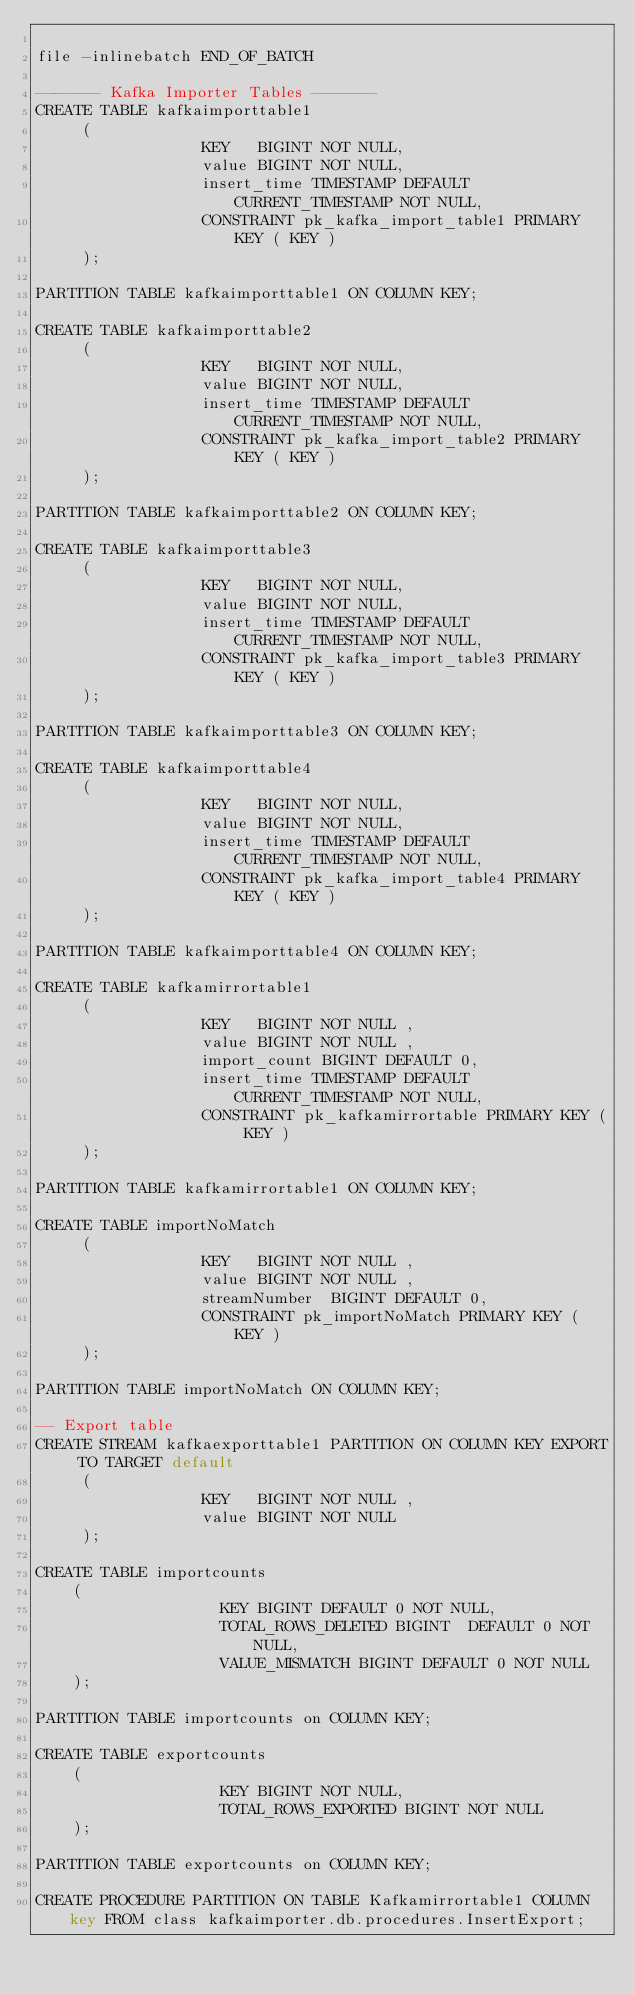<code> <loc_0><loc_0><loc_500><loc_500><_SQL_>
file -inlinebatch END_OF_BATCH

------- Kafka Importer Tables -------
CREATE TABLE kafkaimporttable1
     (
                  KEY   BIGINT NOT NULL,
                  value BIGINT NOT NULL,
                  insert_time TIMESTAMP DEFAULT CURRENT_TIMESTAMP NOT NULL,
                  CONSTRAINT pk_kafka_import_table1 PRIMARY KEY ( KEY )
     );

PARTITION TABLE kafkaimporttable1 ON COLUMN KEY;

CREATE TABLE kafkaimporttable2
     (
                  KEY   BIGINT NOT NULL,
                  value BIGINT NOT NULL,
                  insert_time TIMESTAMP DEFAULT CURRENT_TIMESTAMP NOT NULL,
                  CONSTRAINT pk_kafka_import_table2 PRIMARY KEY ( KEY )
     );

PARTITION TABLE kafkaimporttable2 ON COLUMN KEY;

CREATE TABLE kafkaimporttable3
     (
                  KEY   BIGINT NOT NULL,
                  value BIGINT NOT NULL,
                  insert_time TIMESTAMP DEFAULT CURRENT_TIMESTAMP NOT NULL,
                  CONSTRAINT pk_kafka_import_table3 PRIMARY KEY ( KEY )
     );

PARTITION TABLE kafkaimporttable3 ON COLUMN KEY;

CREATE TABLE kafkaimporttable4
     (
                  KEY   BIGINT NOT NULL,
                  value BIGINT NOT NULL,
                  insert_time TIMESTAMP DEFAULT CURRENT_TIMESTAMP NOT NULL,
                  CONSTRAINT pk_kafka_import_table4 PRIMARY KEY ( KEY )
     );

PARTITION TABLE kafkaimporttable4 ON COLUMN KEY;

CREATE TABLE kafkamirrortable1
     (
                  KEY   BIGINT NOT NULL ,
                  value BIGINT NOT NULL ,
                  import_count BIGINT DEFAULT 0,
                  insert_time TIMESTAMP DEFAULT CURRENT_TIMESTAMP NOT NULL,
                  CONSTRAINT pk_kafkamirrortable PRIMARY KEY ( KEY )
     );

PARTITION TABLE kafkamirrortable1 ON COLUMN KEY;

CREATE TABLE importNoMatch
     (
                  KEY   BIGINT NOT NULL ,
                  value BIGINT NOT NULL ,
                  streamNumber  BIGINT DEFAULT 0,
                  CONSTRAINT pk_importNoMatch PRIMARY KEY ( KEY )
     );

PARTITION TABLE importNoMatch ON COLUMN KEY;

-- Export table
CREATE STREAM kafkaexporttable1 PARTITION ON COLUMN KEY EXPORT TO TARGET default
     (
                  KEY   BIGINT NOT NULL ,
                  value BIGINT NOT NULL
     );

CREATE TABLE importcounts
    (
                    KEY BIGINT DEFAULT 0 NOT NULL,
                    TOTAL_ROWS_DELETED BIGINT  DEFAULT 0 NOT NULL,
                    VALUE_MISMATCH BIGINT DEFAULT 0 NOT NULL
    );

PARTITION TABLE importcounts on COLUMN KEY;

CREATE TABLE exportcounts
    (
                    KEY BIGINT NOT NULL,
                    TOTAL_ROWS_EXPORTED BIGINT NOT NULL
    );

PARTITION TABLE exportcounts on COLUMN KEY;

CREATE PROCEDURE PARTITION ON TABLE Kafkamirrortable1 COLUMN key FROM class kafkaimporter.db.procedures.InsertExport;
</code> 